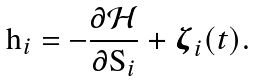Convert formula to latex. <formula><loc_0><loc_0><loc_500><loc_500>\mathbf h _ { i } = - \frac { \partial \mathcal { H } } { \partial \mathbf S _ { i } } + \boldsymbol \zeta _ { i } ( t ) .</formula> 